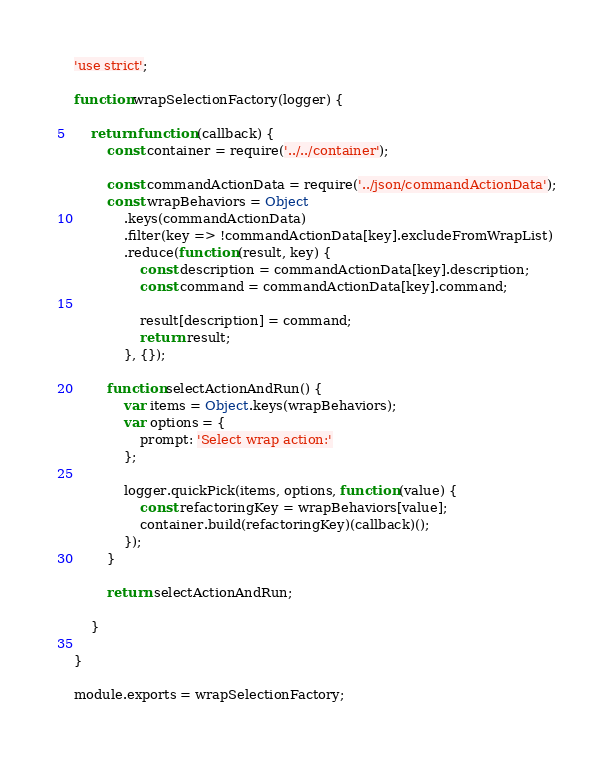Convert code to text. <code><loc_0><loc_0><loc_500><loc_500><_JavaScript_>'use strict';

function wrapSelectionFactory(logger) {

    return function (callback) {
        const container = require('../../container');

        const commandActionData = require('../json/commandActionData');
        const wrapBehaviors = Object
            .keys(commandActionData)
            .filter(key => !commandActionData[key].excludeFromWrapList)
            .reduce(function (result, key) {
                const description = commandActionData[key].description;
                const command = commandActionData[key].command;

                result[description] = command;
                return result;
            }, {});

        function selectActionAndRun() {
            var items = Object.keys(wrapBehaviors);
            var options = {
                prompt: 'Select wrap action:'
            };

            logger.quickPick(items, options, function (value) {
                const refactoringKey = wrapBehaviors[value];
                container.build(refactoringKey)(callback)();
            });
        }

        return selectActionAndRun;

    }

}

module.exports = wrapSelectionFactory;</code> 